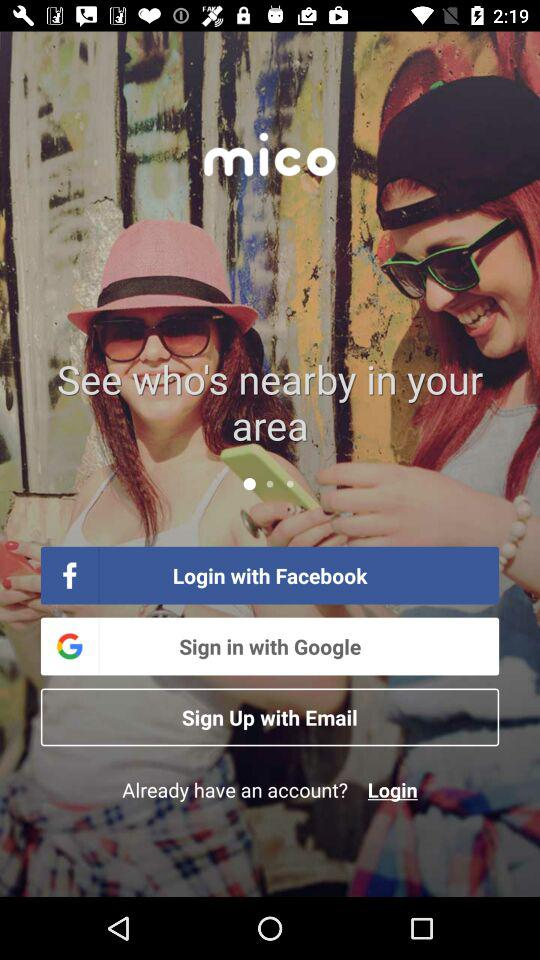What are the different options available to sign in? The different options available to sign in are: "Login with Facebook" and "Sign in with Google". 